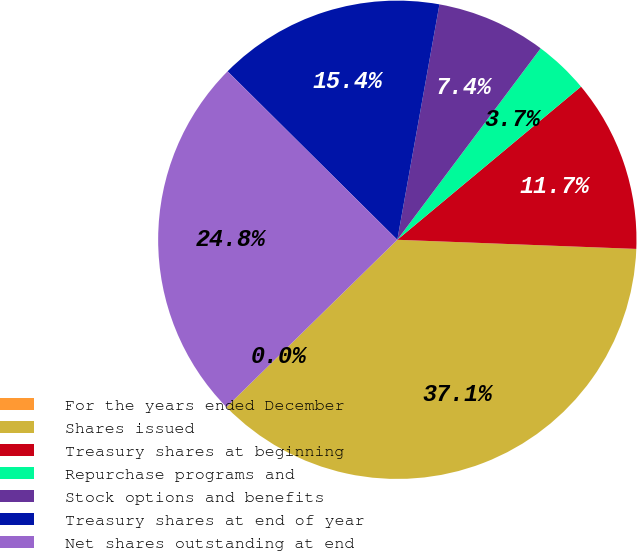<chart> <loc_0><loc_0><loc_500><loc_500><pie_chart><fcel>For the years ended December<fcel>Shares issued<fcel>Treasury shares at beginning<fcel>Repurchase programs and<fcel>Stock options and benefits<fcel>Treasury shares at end of year<fcel>Net shares outstanding at end<nl><fcel>0.0%<fcel>37.06%<fcel>11.67%<fcel>3.71%<fcel>7.41%<fcel>15.38%<fcel>24.77%<nl></chart> 